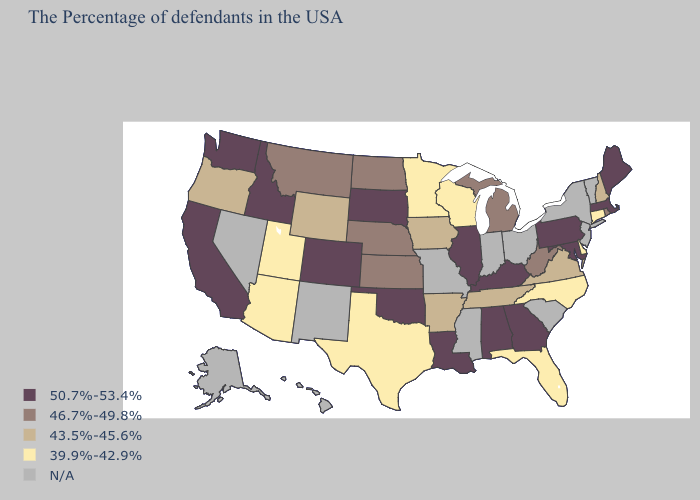Name the states that have a value in the range 43.5%-45.6%?
Keep it brief. New Hampshire, Virginia, Tennessee, Arkansas, Iowa, Wyoming, Oregon. What is the lowest value in states that border Illinois?
Give a very brief answer. 39.9%-42.9%. Name the states that have a value in the range 43.5%-45.6%?
Be succinct. New Hampshire, Virginia, Tennessee, Arkansas, Iowa, Wyoming, Oregon. Name the states that have a value in the range 39.9%-42.9%?
Concise answer only. Connecticut, Delaware, North Carolina, Florida, Wisconsin, Minnesota, Texas, Utah, Arizona. How many symbols are there in the legend?
Quick response, please. 5. Does Arizona have the lowest value in the USA?
Quick response, please. Yes. Name the states that have a value in the range N/A?
Short answer required. Vermont, New York, New Jersey, South Carolina, Ohio, Indiana, Mississippi, Missouri, New Mexico, Nevada, Alaska, Hawaii. What is the highest value in the USA?
Short answer required. 50.7%-53.4%. Does Colorado have the lowest value in the West?
Keep it brief. No. Is the legend a continuous bar?
Concise answer only. No. Which states have the lowest value in the West?
Keep it brief. Utah, Arizona. What is the value of South Dakota?
Answer briefly. 50.7%-53.4%. Name the states that have a value in the range 50.7%-53.4%?
Give a very brief answer. Maine, Massachusetts, Maryland, Pennsylvania, Georgia, Kentucky, Alabama, Illinois, Louisiana, Oklahoma, South Dakota, Colorado, Idaho, California, Washington. What is the value of Indiana?
Be succinct. N/A. 